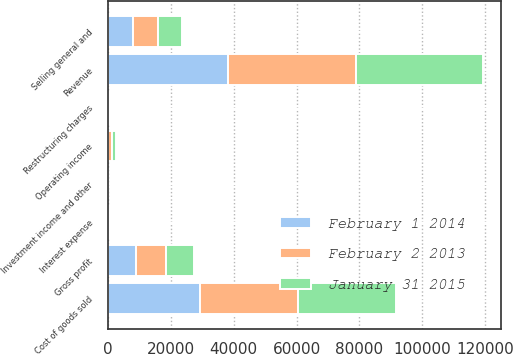Convert chart. <chart><loc_0><loc_0><loc_500><loc_500><stacked_bar_chart><ecel><fcel>Revenue<fcel>Cost of goods sold<fcel>Gross profit<fcel>Selling general and<fcel>Restructuring charges<fcel>Operating income<fcel>Investment income and other<fcel>Interest expense<nl><fcel>January 31 2015<fcel>40339<fcel>31292<fcel>9047<fcel>7592<fcel>5<fcel>1450<fcel>14<fcel>90<nl><fcel>February 2 2013<fcel>40611<fcel>31212<fcel>9399<fcel>8106<fcel>149<fcel>1144<fcel>19<fcel>100<nl><fcel>February 1 2014<fcel>38252<fcel>29228<fcel>9023<fcel>7905<fcel>414<fcel>90<fcel>13<fcel>99<nl></chart> 